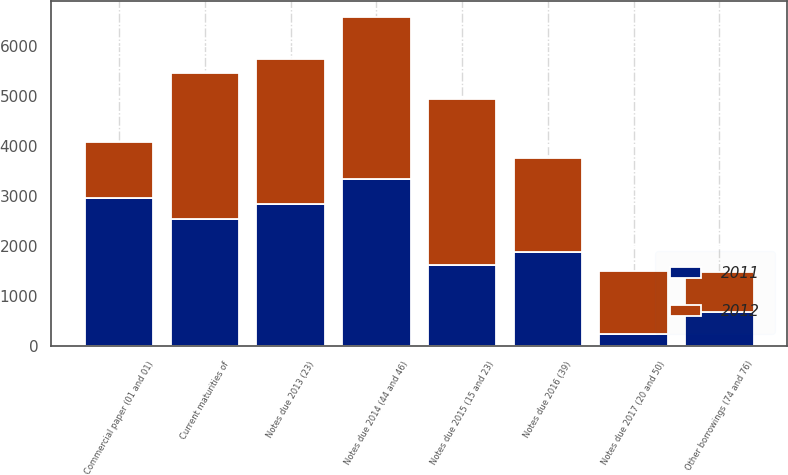Convert chart. <chart><loc_0><loc_0><loc_500><loc_500><stacked_bar_chart><ecel><fcel>Current maturities of<fcel>Commercial paper (01 and 01)<fcel>Other borrowings (74 and 76)<fcel>Notes due 2013 (23)<fcel>Notes due 2014 (44 and 46)<fcel>Notes due 2015 (15 and 23)<fcel>Notes due 2016 (39)<fcel>Notes due 2017 (20 and 50)<nl><fcel>2012<fcel>2901<fcel>1101<fcel>813<fcel>2891<fcel>3237<fcel>3300<fcel>1878<fcel>1250<nl><fcel>2011<fcel>2549<fcel>2973<fcel>683<fcel>2841<fcel>3335<fcel>1632<fcel>1876<fcel>258<nl></chart> 